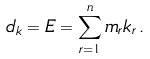<formula> <loc_0><loc_0><loc_500><loc_500>d _ { k } = E = \sum _ { r = 1 } ^ { n } m _ { r } k _ { r } \, .</formula> 